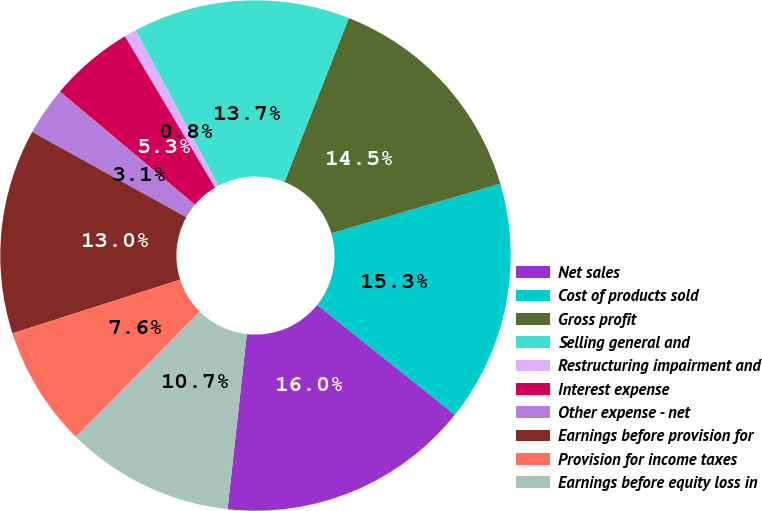<chart> <loc_0><loc_0><loc_500><loc_500><pie_chart><fcel>Net sales<fcel>Cost of products sold<fcel>Gross profit<fcel>Selling general and<fcel>Restructuring impairment and<fcel>Interest expense<fcel>Other expense - net<fcel>Earnings before provision for<fcel>Provision for income taxes<fcel>Earnings before equity loss in<nl><fcel>16.03%<fcel>15.26%<fcel>14.5%<fcel>13.74%<fcel>0.77%<fcel>5.35%<fcel>3.06%<fcel>12.98%<fcel>7.63%<fcel>10.69%<nl></chart> 